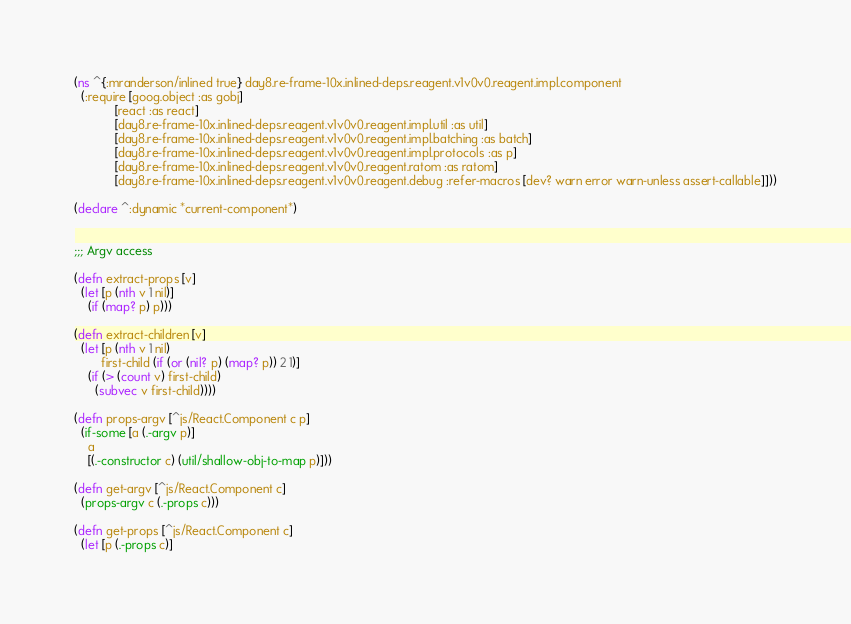<code> <loc_0><loc_0><loc_500><loc_500><_Clojure_>(ns ^{:mranderson/inlined true} day8.re-frame-10x.inlined-deps.reagent.v1v0v0.reagent.impl.component
  (:require [goog.object :as gobj]
            [react :as react]
            [day8.re-frame-10x.inlined-deps.reagent.v1v0v0.reagent.impl.util :as util]
            [day8.re-frame-10x.inlined-deps.reagent.v1v0v0.reagent.impl.batching :as batch]
            [day8.re-frame-10x.inlined-deps.reagent.v1v0v0.reagent.impl.protocols :as p]
            [day8.re-frame-10x.inlined-deps.reagent.v1v0v0.reagent.ratom :as ratom]
            [day8.re-frame-10x.inlined-deps.reagent.v1v0v0.reagent.debug :refer-macros [dev? warn error warn-unless assert-callable]]))

(declare ^:dynamic *current-component*)


;;; Argv access

(defn extract-props [v]
  (let [p (nth v 1 nil)]
    (if (map? p) p)))

(defn extract-children [v]
  (let [p (nth v 1 nil)
        first-child (if (or (nil? p) (map? p)) 2 1)]
    (if (> (count v) first-child)
      (subvec v first-child))))

(defn props-argv [^js/React.Component c p]
  (if-some [a (.-argv p)]
    a
    [(.-constructor c) (util/shallow-obj-to-map p)]))

(defn get-argv [^js/React.Component c]
  (props-argv c (.-props c)))

(defn get-props [^js/React.Component c]
  (let [p (.-props c)]</code> 